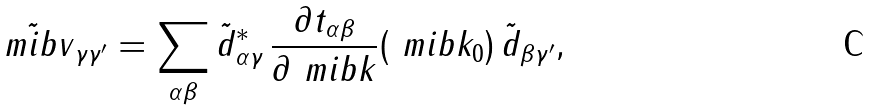<formula> <loc_0><loc_0><loc_500><loc_500>\tilde { \ m i b { v } } _ { \gamma \gamma ^ { \prime } } & = \sum _ { \alpha \beta } \tilde { d } ^ { * } _ { \alpha \gamma } \, \frac { \partial t _ { \alpha \beta } } { \partial \ m i b { k } } ( \ m i b { k } _ { 0 } ) \, \tilde { d } _ { \beta \gamma ^ { \prime } } ,</formula> 